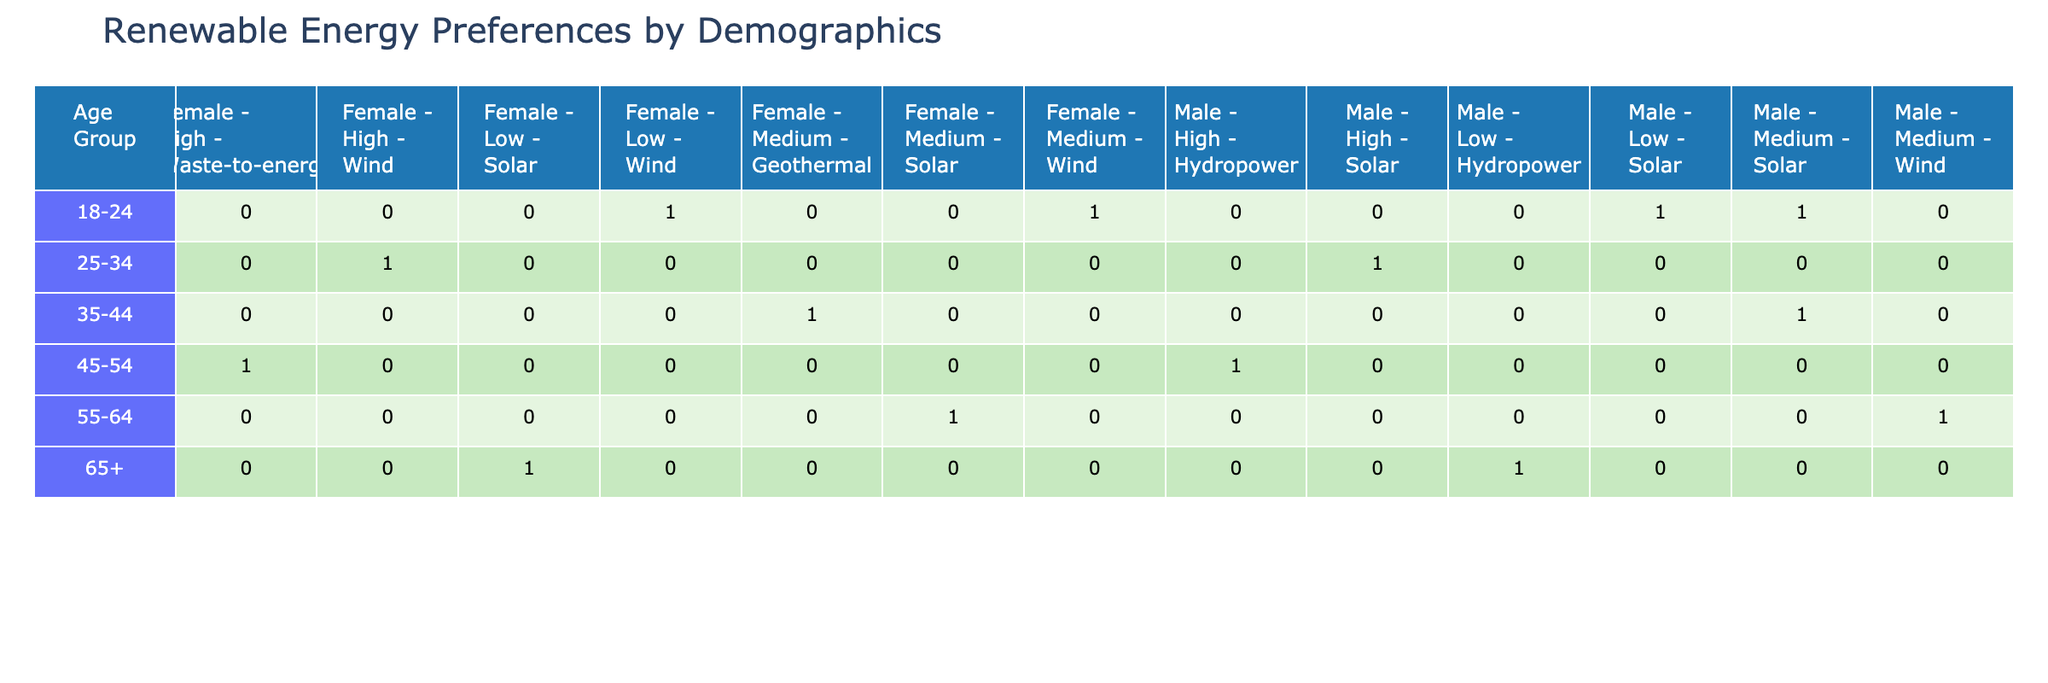What renewable energy source is most preferred by males aged 18-24? There are two entries for males aged 18-24. Both preferred solar energy, thus making solar the most preferred source among this demographic.
Answer: Solar What is the preferred renewable energy source for females aged 35-44? There is one entry for females aged 35-44, which indicates that their preferred renewable energy source is geothermal.
Answer: Geothermal How many individuals in total prefer solar energy? By counting the entries for solar energy in the table, we find three individuals prefer solar: two from the 18-24 age group and one from the 55-64 age group.
Answer: 3 Are there any females in the table who prefer hydropower? Checking the data, there is one entry for females preferring hydropower in the 45-54 age group. Hence, the answer is yes.
Answer: Yes What is the average income level of males preferring wind energy? Males preferring wind energy are from two income levels: low (18-24 age group) and medium (55-64 age group). Therefore, their average income level is (Low + Medium)/2, or (1 + 2)/2 = 1.5 which indicates the average is between low and medium.
Answer: Between low and medium Which demographic group shows a preference for waste-to-energy? Females aged 45-54 are noted for preferring waste-to-energy, as seen in the corresponding row of the table.
Answer: Females aged 45-54 How many preferences for renewable energy sources are recorded for the income level 'High'? There are three entries where high-income level respondents preferred: wind (females, 25-34), solar (males, 25-34), and waste-to-energy (females, 45-54). Therefore, the total count is 3.
Answer: 3 Do seniors (ages 65+) show any preference for wind energy? By examining the data for seniors, it is clear there are two entries for this age group that indicate a preference for hydropower and solar, hence they do not prefer wind energy.
Answer: No Which age group has the highest number of diverse renewable energy preferences? The 18-24 age group has two different preferences (solar and wind), while other age groups have fewer varied choices, indicating that this group has the highest diversity in preferences.
Answer: 18-24 age group 